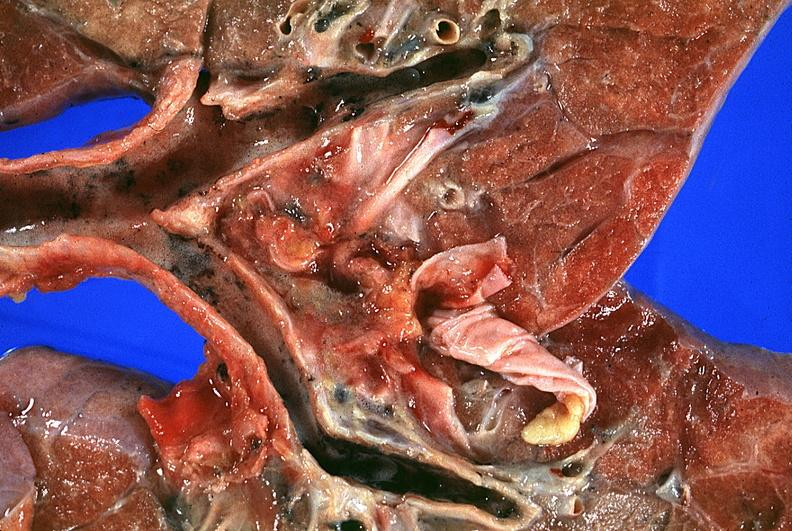does cytomegalovirus show lung?
Answer the question using a single word or phrase. No 